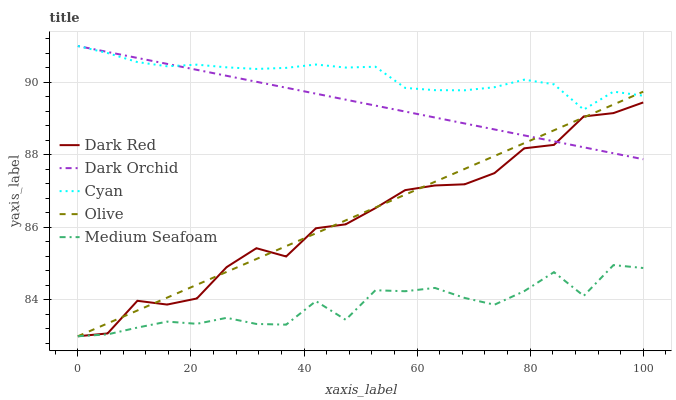Does Medium Seafoam have the minimum area under the curve?
Answer yes or no. Yes. Does Cyan have the maximum area under the curve?
Answer yes or no. Yes. Does Dark Red have the minimum area under the curve?
Answer yes or no. No. Does Dark Red have the maximum area under the curve?
Answer yes or no. No. Is Dark Orchid the smoothest?
Answer yes or no. Yes. Is Medium Seafoam the roughest?
Answer yes or no. Yes. Is Dark Red the smoothest?
Answer yes or no. No. Is Dark Red the roughest?
Answer yes or no. No. Does Olive have the lowest value?
Answer yes or no. Yes. Does Dark Orchid have the lowest value?
Answer yes or no. No. Does Cyan have the highest value?
Answer yes or no. Yes. Does Dark Red have the highest value?
Answer yes or no. No. Is Medium Seafoam less than Dark Orchid?
Answer yes or no. Yes. Is Dark Orchid greater than Medium Seafoam?
Answer yes or no. Yes. Does Olive intersect Dark Red?
Answer yes or no. Yes. Is Olive less than Dark Red?
Answer yes or no. No. Is Olive greater than Dark Red?
Answer yes or no. No. Does Medium Seafoam intersect Dark Orchid?
Answer yes or no. No. 